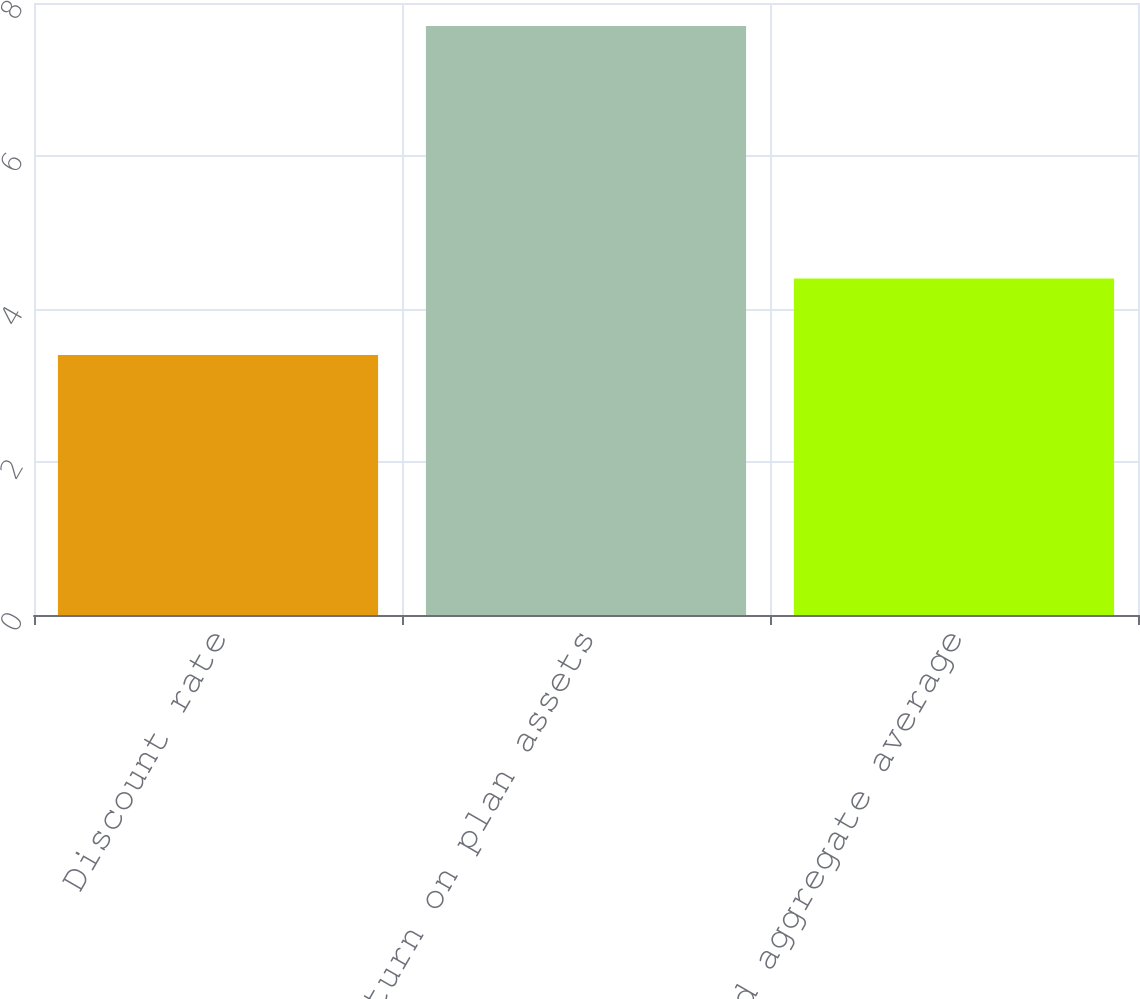Convert chart. <chart><loc_0><loc_0><loc_500><loc_500><bar_chart><fcel>Discount rate<fcel>Expected return on plan assets<fcel>Expected aggregate average<nl><fcel>3.4<fcel>7.7<fcel>4.4<nl></chart> 